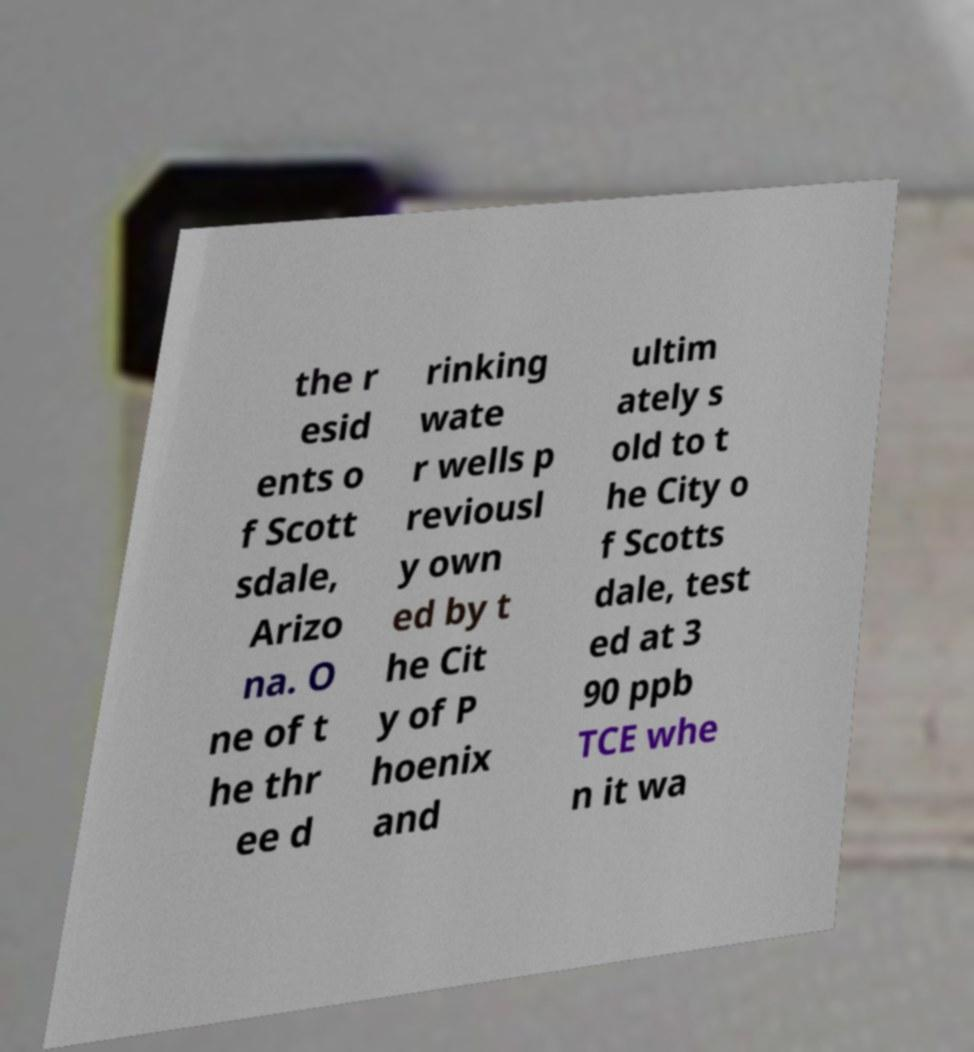Could you extract and type out the text from this image? the r esid ents o f Scott sdale, Arizo na. O ne of t he thr ee d rinking wate r wells p reviousl y own ed by t he Cit y of P hoenix and ultim ately s old to t he City o f Scotts dale, test ed at 3 90 ppb TCE whe n it wa 